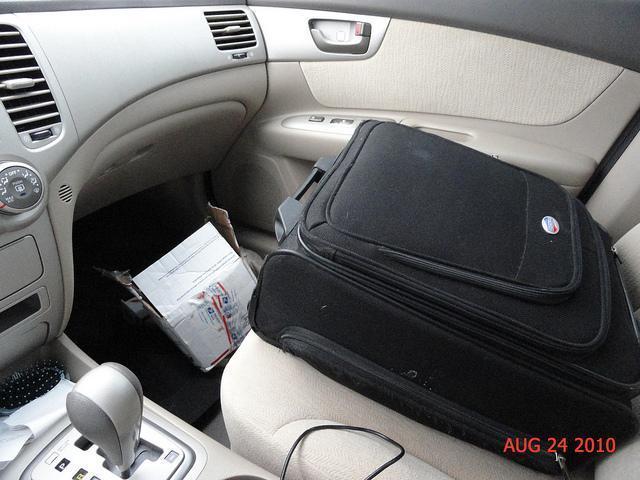How many men are riding skateboards?
Give a very brief answer. 0. 